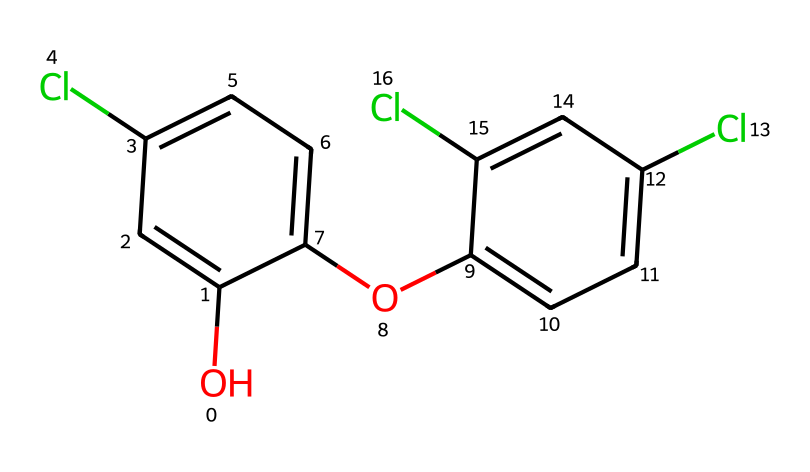What is the main functional group present in triclosan? The chemical structure of triclosan features a hydroxyl group (OH), indicating that it is an alcohol. This is visible at the beginning of the SMILES representation.
Answer: hydroxyl group How many chlorine atoms are in the structure of triclosan? By examining the SMILES representation, we can count that there are three instances of "Cl", which represent chlorine atoms. Therefore, the total is three.
Answer: three What type of bond connects the carbon atoms in triclosan? The structure shows multiple carbon-carbon connections, most of which are implied to be single bonds since no double bonds are indicated besides those potentially in the aromatic rings.
Answer: single bonds What is the total number of aromatic rings in the triclosan structure? Two benzene rings are easily identified from the structure in the chemical representation, as they are highlighted by alternating double bonds in two distinct parts of the structure.
Answer: two Does triclosan contain any nitrogen atoms? The SMILES notation does not include any 'N' symbol, indicating the absence of nitrogen atoms in the structure of triclosan.
Answer: no Is triclosan considered hydrophobic or hydrophilic based on its structure? The presence of both the hydroxyl group and the aromatic rings suggests that triclosan has significant hydrophilic character due to the polar nature of the hydroxyl group, while the hydrophobic aromatic rings contribute to its overall behavior.
Answer: hydrophilic What is the molecular formula for triclosan based on its structure? By counting the atoms indicated in the SMILES, we determine that the molecular formula includes 12 carbons, 9 hydrogens, 3 chlorines, and 1 oxygen, forming C12H9Cl3O.
Answer: C12H9Cl3O 